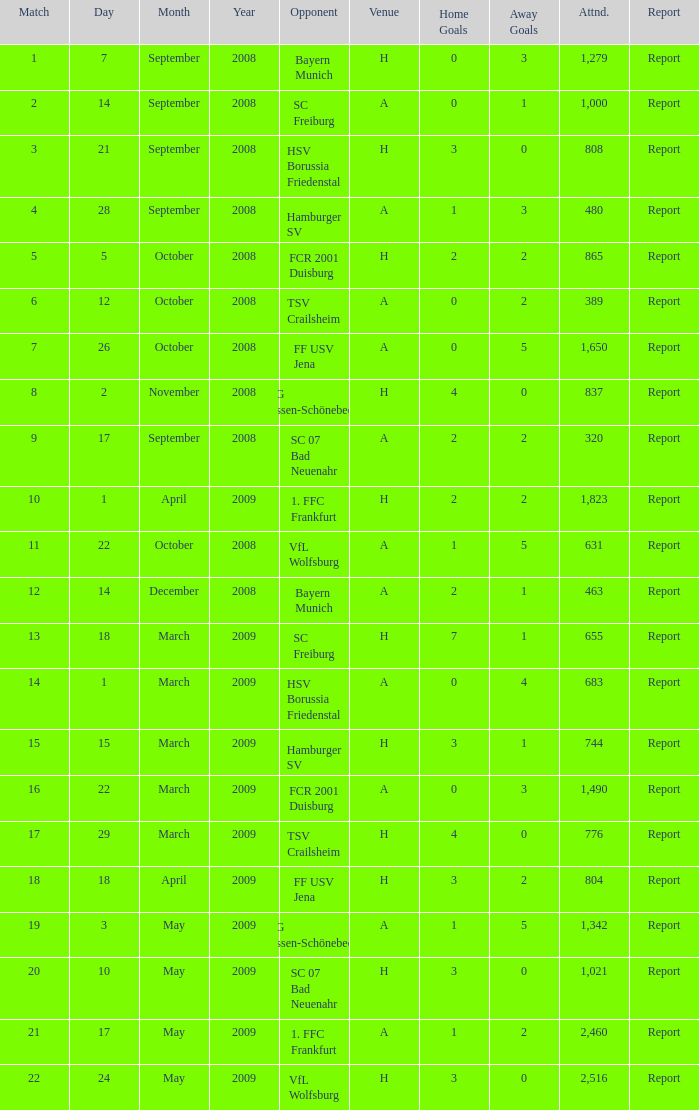Which match had more than 1,490 people in attendance to watch FCR 2001 Duisburg have a result of 0:3 (0:2)? None. 